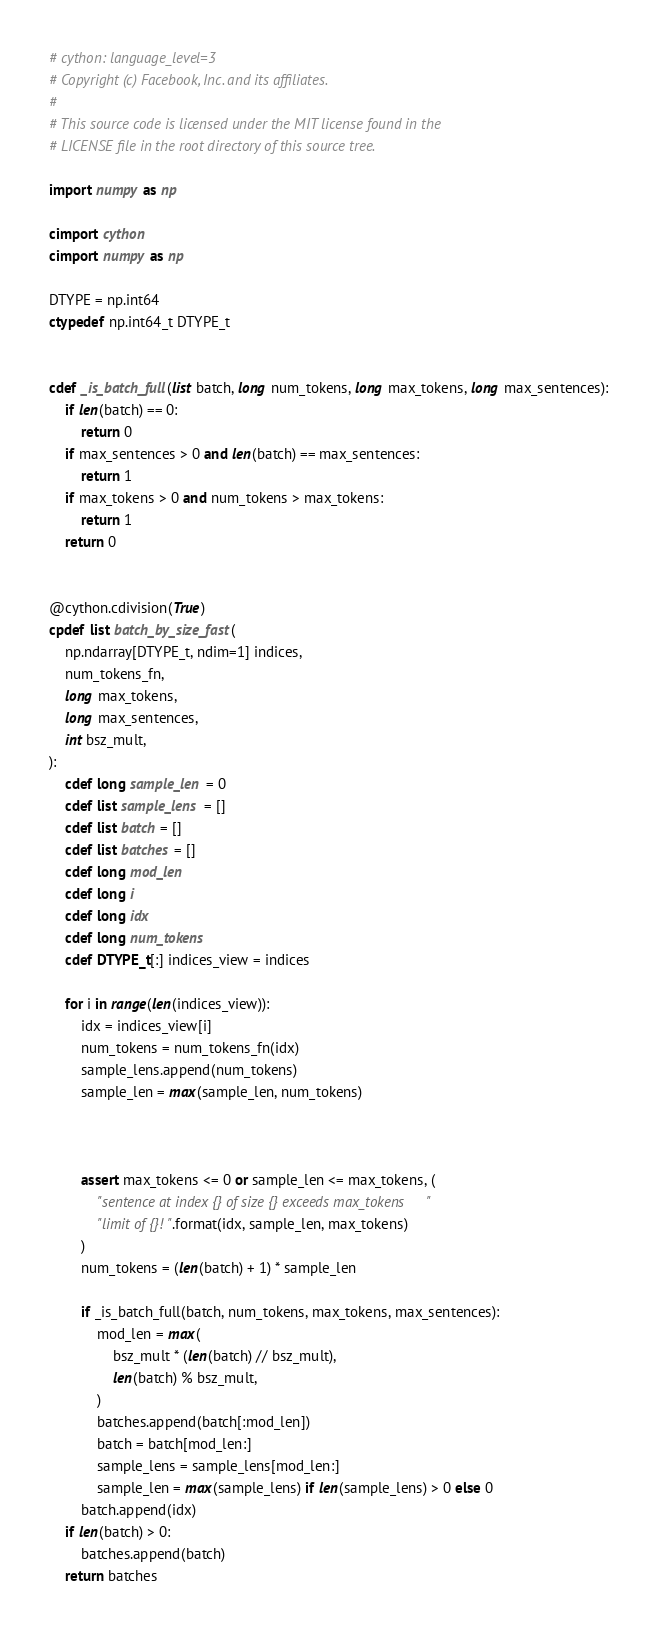Convert code to text. <code><loc_0><loc_0><loc_500><loc_500><_Cython_># cython: language_level=3
# Copyright (c) Facebook, Inc. and its affiliates.
#
# This source code is licensed under the MIT license found in the
# LICENSE file in the root directory of this source tree.

import numpy as np

cimport cython
cimport numpy as np

DTYPE = np.int64
ctypedef np.int64_t DTYPE_t


cdef _is_batch_full(list batch, long num_tokens, long max_tokens, long max_sentences):
    if len(batch) == 0:
        return 0
    if max_sentences > 0 and len(batch) == max_sentences:
        return 1
    if max_tokens > 0 and num_tokens > max_tokens:
        return 1
    return 0


@cython.cdivision(True)
cpdef list batch_by_size_fast(
    np.ndarray[DTYPE_t, ndim=1] indices,
    num_tokens_fn,
    long max_tokens,
    long max_sentences,
    int bsz_mult,
):
    cdef long sample_len = 0
    cdef list sample_lens = []
    cdef list batch = []
    cdef list batches = []
    cdef long mod_len
    cdef long i
    cdef long idx
    cdef long num_tokens
    cdef DTYPE_t[:] indices_view = indices

    for i in range(len(indices_view)):
        idx = indices_view[i]
        num_tokens = num_tokens_fn(idx)
        sample_lens.append(num_tokens)
        sample_len = max(sample_len, num_tokens)

        
        
        assert max_tokens <= 0 or sample_len <= max_tokens, (
            "sentence at index {} of size {} exceeds max_tokens "
            "limit of {}!".format(idx, sample_len, max_tokens)
        )
        num_tokens = (len(batch) + 1) * sample_len

        if _is_batch_full(batch, num_tokens, max_tokens, max_sentences):
            mod_len = max(
                bsz_mult * (len(batch) // bsz_mult),
                len(batch) % bsz_mult,
            )
            batches.append(batch[:mod_len])
            batch = batch[mod_len:]
            sample_lens = sample_lens[mod_len:]
            sample_len = max(sample_lens) if len(sample_lens) > 0 else 0
        batch.append(idx)
    if len(batch) > 0:
        batches.append(batch)
    return batches
</code> 